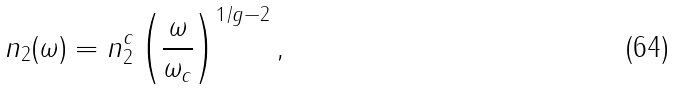Convert formula to latex. <formula><loc_0><loc_0><loc_500><loc_500>n _ { 2 } ( \omega ) = n ^ { c } _ { 2 } \left ( \frac { \omega } { \omega _ { c } } \right ) ^ { 1 / g - 2 } ,</formula> 